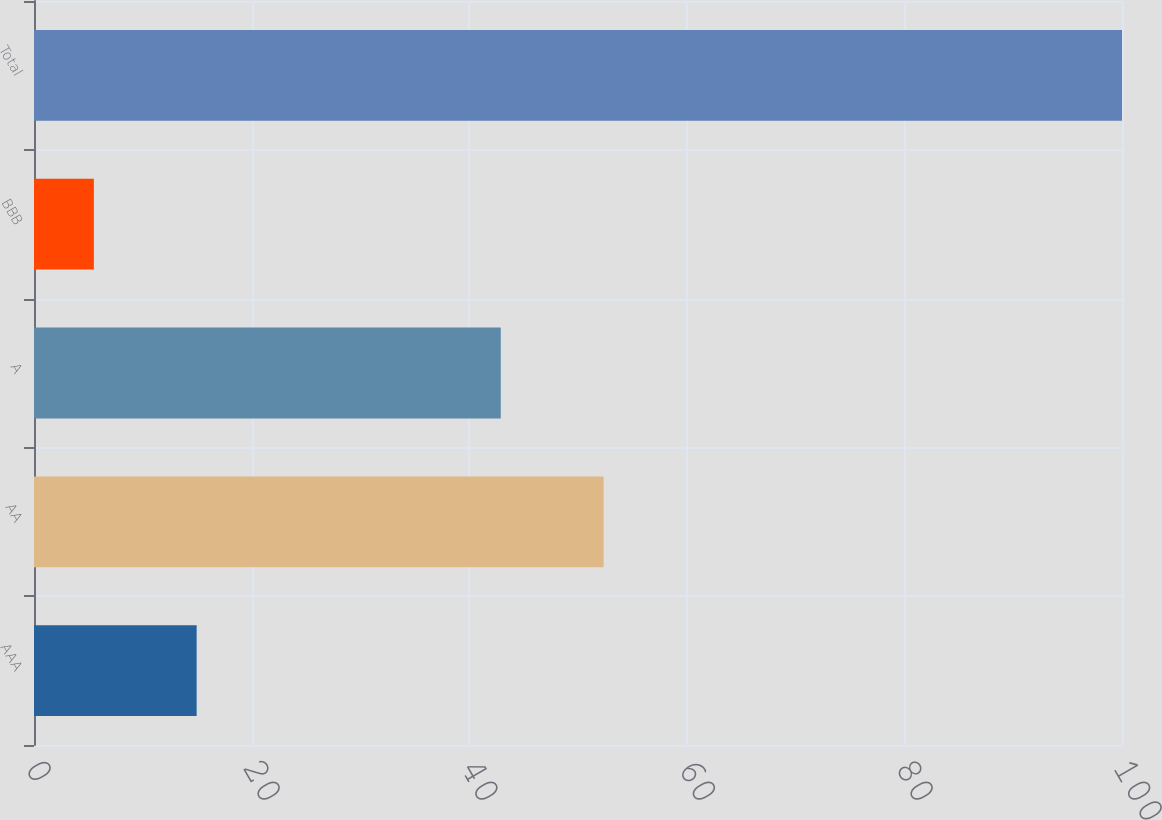Convert chart to OTSL. <chart><loc_0><loc_0><loc_500><loc_500><bar_chart><fcel>AAA<fcel>AA<fcel>A<fcel>BBB<fcel>Total<nl><fcel>14.95<fcel>52.35<fcel>42.9<fcel>5.5<fcel>100<nl></chart> 